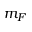<formula> <loc_0><loc_0><loc_500><loc_500>m _ { F }</formula> 